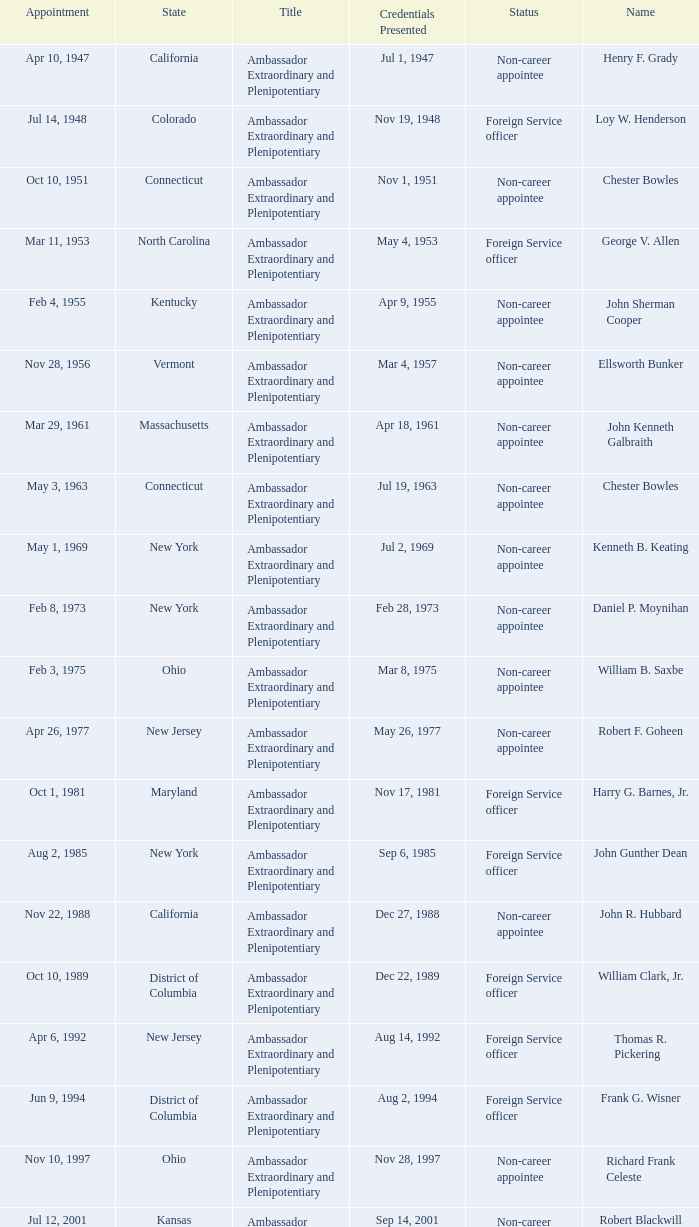What day was the appointment when Credentials Presented was jul 2, 1969? May 1, 1969. 